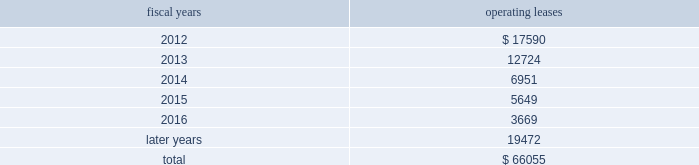The following is a schedule of future minimum rental payments required under long-term operating leases at october 29 , 2011 : fiscal years operating leases .
12 .
Commitments and contingencies from time to time in the ordinary course of the company 2019s business , various claims , charges and litigation are asserted or commenced against the company arising from , or related to , contractual matters , patents , trademarks , personal injury , environmental matters , product liability , insurance coverage and personnel and employment disputes .
As to such claims and litigation , the company can give no assurance that it will prevail .
The company does not believe that any current legal matters will have a material adverse effect on the company 2019s financial position , results of operations or cash flows .
13 .
Retirement plans the company and its subsidiaries have various savings and retirement plans covering substantially all employees .
The company maintains a defined contribution plan for the benefit of its eligible u.s .
Employees .
This plan provides for company contributions of up to 5% ( 5 % ) of each participant 2019s total eligible compensation .
In addition , the company contributes an amount equal to each participant 2019s pre-tax contribution , if any , up to a maximum of 3% ( 3 % ) of each participant 2019s total eligible compensation .
The total expense related to the defined contribution plan for u.s .
Employees was $ 21.9 million in fiscal 2011 , $ 20.5 million in fiscal 2010 and $ 21.5 million in fiscal 2009 .
The company also has various defined benefit pension and other retirement plans for certain non-u.s .
Employees that are consistent with local statutory requirements and practices .
The total expense related to the various defined benefit pension and other retirement plans for certain non-u.s .
Employees was $ 21.4 million in fiscal 2011 , $ 11.7 million in fiscal 2010 and $ 10.9 million in fiscal 2009 .
Non-u.s .
Plan disclosures the company 2019s funding policy for its foreign defined benefit pension plans is consistent with the local requirements of each country .
The plans 2019 assets consist primarily of u.s .
And non-u.s .
Equity securities , bonds , property and cash .
The benefit obligations and related assets under these plans have been measured at october 29 , 2011 and october 30 , 2010 .
Analog devices , inc .
Notes to consolidated financial statements 2014 ( continued ) .
What is the growth rate in the total expense related to the defined contribution plan for non-u.s.employees in 2011? 
Computations: ((21.4 - 11.7) / 11.7)
Answer: 0.82906. 